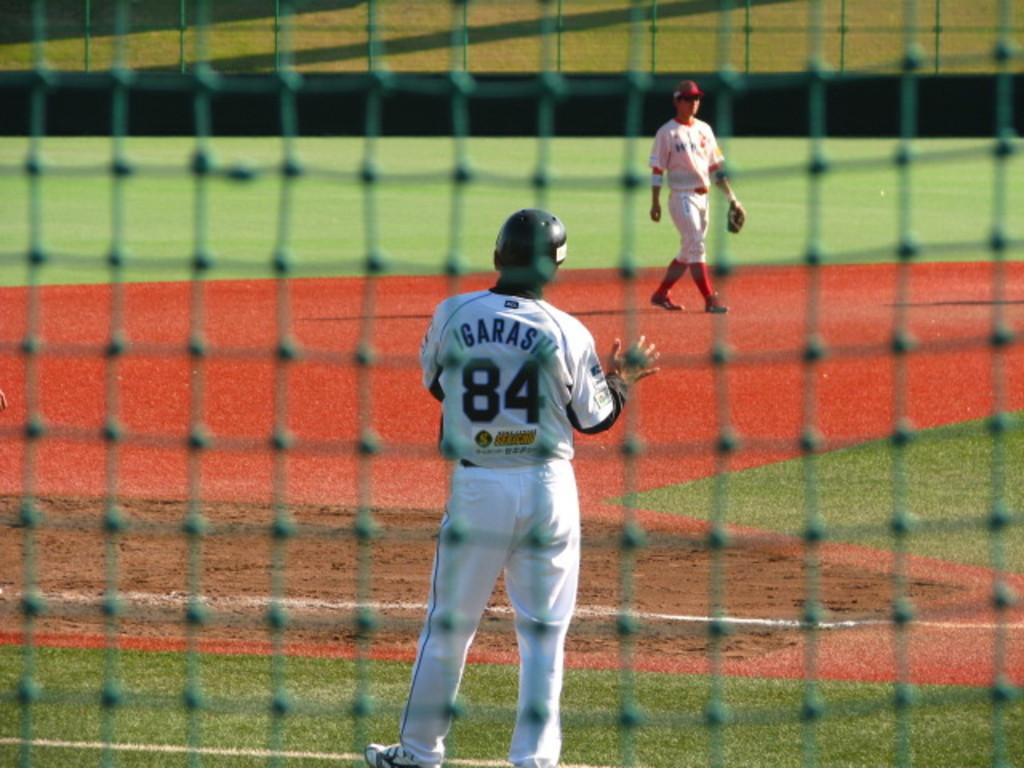What name is written above the number 84?
Make the answer very short. Garas. 